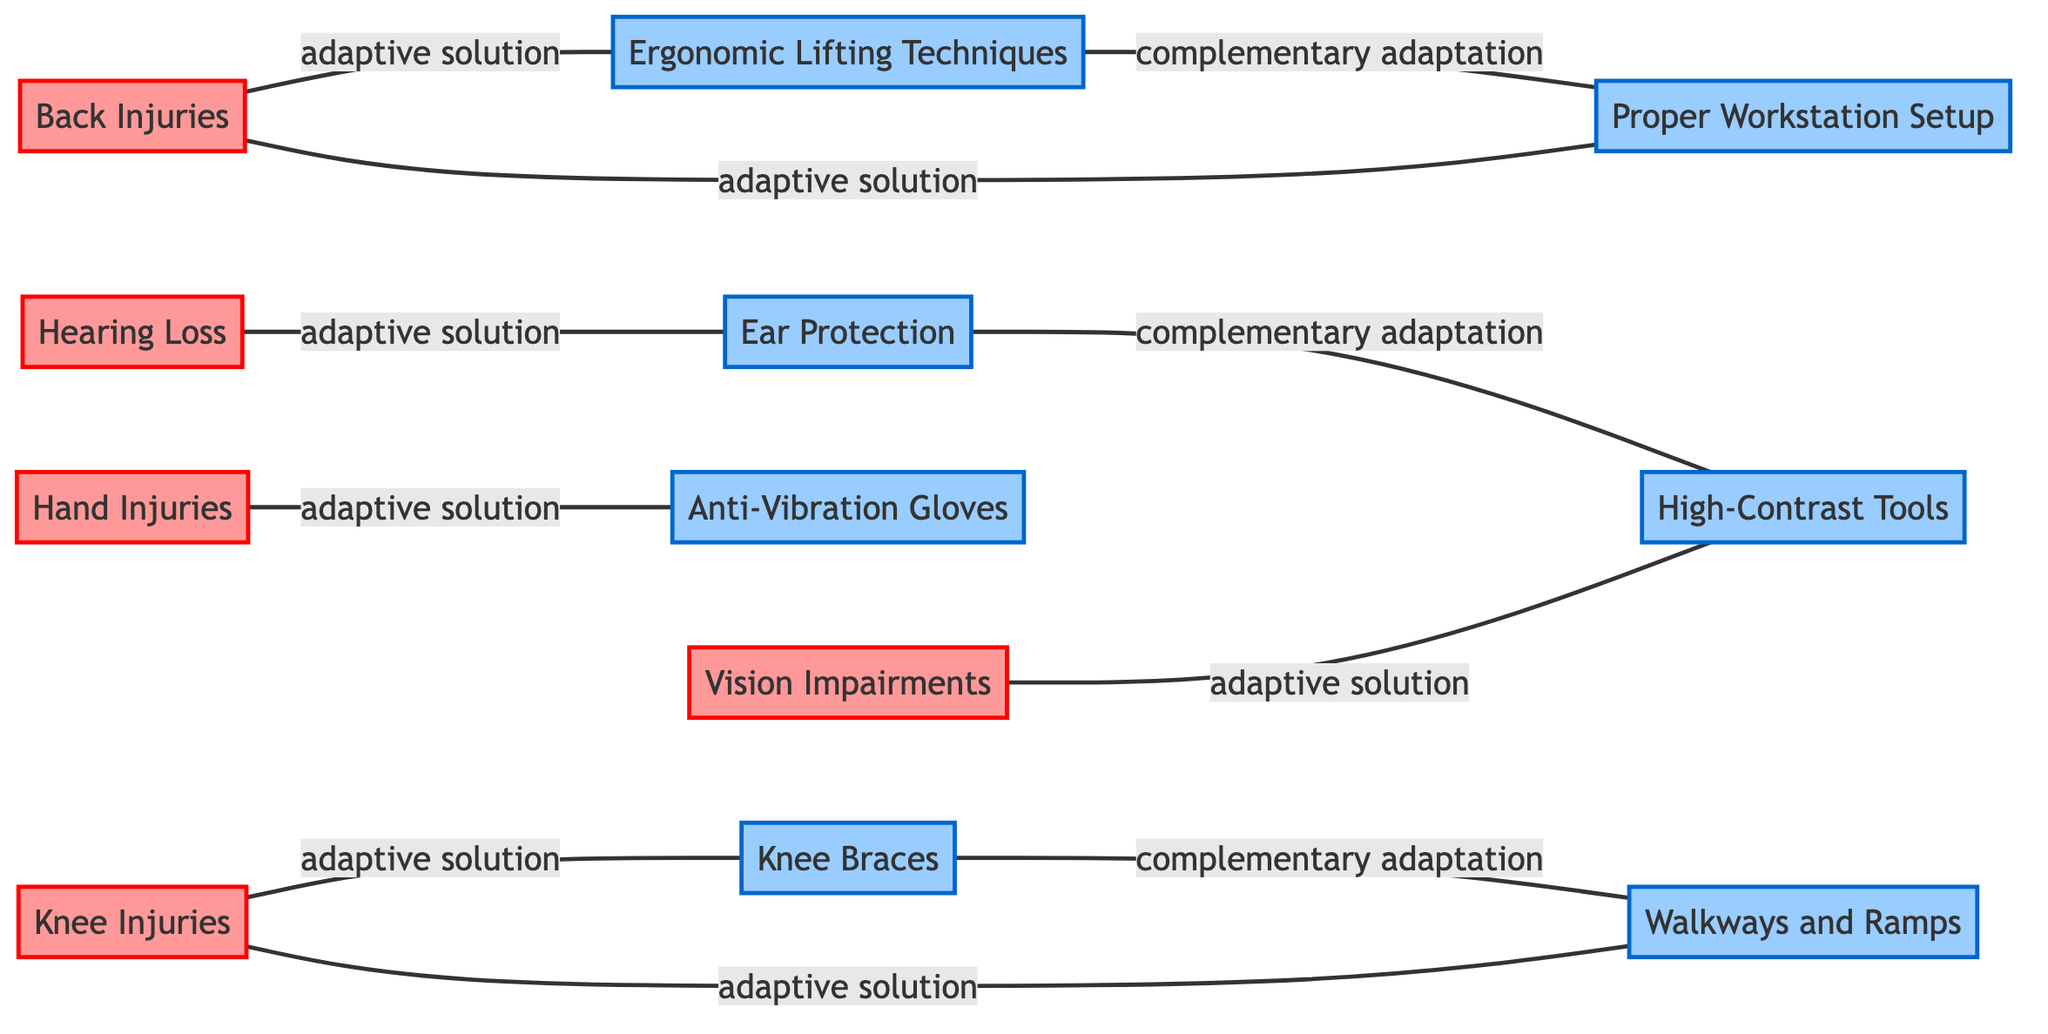What are the two adaptive solutions linked to Back Injuries? The diagram shows two edges connected to the node "Back Injuries". The first edge connects to "Ergonomic Lifting Techniques" and the second edge connects to "Proper Workstation Setup".
Answer: Ergonomic Lifting Techniques, Proper Workstation Setup Which injury is connected to Anti-Vibration Gloves? The edge from the node "Hand Injuries" leads to the node "Anti-Vibration Gloves", indicating that this adaptive solution is related to Hand Injuries.
Answer: Hand Injuries How many nodes represent injuries in this graph? The graph includes five nodes specifically labeled with injuries: Back Injuries, Knee Injuries, Hand Injuries, Hearing Loss, and Vision Impairments. Counting these gives a total of five injury nodes.
Answer: 5 What do Knee Braces and Walkways and Ramps represent in the graph? Both "Knee Braces" and "Walkways and Ramps" are connected to the node "Knee Injuries", showing that they are adaptive solutions to address the condition of Knee Injuries.
Answer: Adaptive solutions How many complementary adaptations are shown in the graph? The graph displays three complementary adaptations: "Knee Braces" to "Walkways and Ramps", "Ergonomic Lifting Techniques" to "Proper Workstation Setup", and "Ear Protection" to "High-Contrast Tools". Counting these gives a total of three complementary adaptations.
Answer: 3 Which adaptive solution is linked to Vision Impairments? The graph indicates that "High-Contrast Tools" is connected to the node "Vision Impairments", thus representing an adaptive solution specifically for this injury.
Answer: High-Contrast Tools What is the relationship between Ear Protection and Hearing Loss? The diagram includes a direct link from the node "Hearing Loss" to "Ear Protection", indicating that Ear Protection serves as an adaptive solution for Hearing Loss.
Answer: Adaptive solution Which two nodes are linked by a complementary adaptation pertaining to ergonomic solutions? The nodes "Ergonomic Lifting Techniques" and "Proper Workstation Setup" are connected through a complementary adaptation, highlighting their relation to ergonomic solutions.
Answer: Ergonomic Lifting Techniques, Proper Workstation Setup 